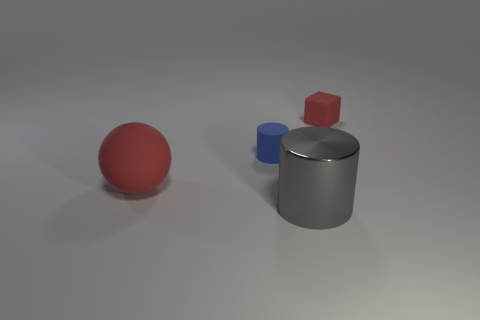Are there any other things that have the same material as the gray cylinder?
Provide a short and direct response. No. There is a red object that is to the left of the red block; are there any big metal objects that are on the right side of it?
Offer a terse response. Yes. There is a object that is the same size as the gray metal cylinder; what is it made of?
Offer a terse response. Rubber. Is there another cylinder that has the same size as the rubber cylinder?
Offer a very short reply. No. What is the material of the cylinder to the left of the big cylinder?
Offer a very short reply. Rubber. Are the cylinder left of the gray metallic thing and the red cube made of the same material?
Provide a short and direct response. Yes. What is the shape of the rubber object that is the same size as the gray metal thing?
Offer a terse response. Sphere. What number of big things have the same color as the small matte block?
Offer a very short reply. 1. Is the number of gray objects that are on the right side of the big cylinder less than the number of tiny red rubber objects that are behind the large red matte thing?
Your answer should be very brief. Yes. Are there any red objects behind the big red matte object?
Provide a short and direct response. Yes. 